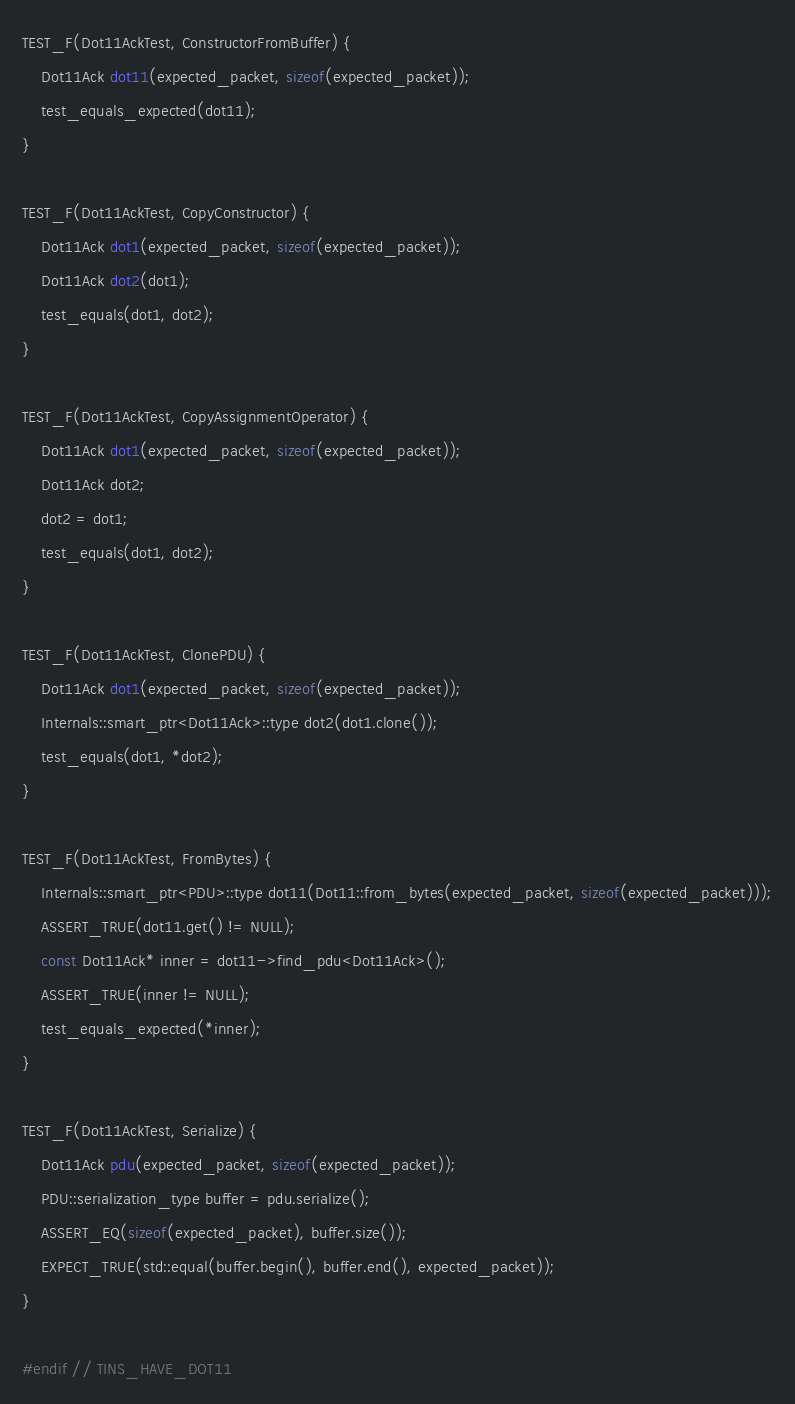Convert code to text. <code><loc_0><loc_0><loc_500><loc_500><_C++_>TEST_F(Dot11AckTest, ConstructorFromBuffer) {
    Dot11Ack dot11(expected_packet, sizeof(expected_packet));
    test_equals_expected(dot11);
}

TEST_F(Dot11AckTest, CopyConstructor) {
    Dot11Ack dot1(expected_packet, sizeof(expected_packet));
    Dot11Ack dot2(dot1);
    test_equals(dot1, dot2);
}

TEST_F(Dot11AckTest, CopyAssignmentOperator) {
    Dot11Ack dot1(expected_packet, sizeof(expected_packet));
    Dot11Ack dot2;
    dot2 = dot1;
    test_equals(dot1, dot2);
}

TEST_F(Dot11AckTest, ClonePDU) {
    Dot11Ack dot1(expected_packet, sizeof(expected_packet));
    Internals::smart_ptr<Dot11Ack>::type dot2(dot1.clone());
    test_equals(dot1, *dot2);
}

TEST_F(Dot11AckTest, FromBytes) {
    Internals::smart_ptr<PDU>::type dot11(Dot11::from_bytes(expected_packet, sizeof(expected_packet)));
    ASSERT_TRUE(dot11.get() != NULL);
    const Dot11Ack* inner = dot11->find_pdu<Dot11Ack>();
    ASSERT_TRUE(inner != NULL);
    test_equals_expected(*inner);
}

TEST_F(Dot11AckTest, Serialize) {
    Dot11Ack pdu(expected_packet, sizeof(expected_packet));
    PDU::serialization_type buffer = pdu.serialize();
    ASSERT_EQ(sizeof(expected_packet), buffer.size());
    EXPECT_TRUE(std::equal(buffer.begin(), buffer.end(), expected_packet));
}

#endif // TINS_HAVE_DOT11
</code> 